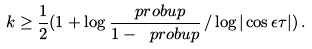Convert formula to latex. <formula><loc_0><loc_0><loc_500><loc_500>k \geq \frac { 1 } { 2 } ( 1 + \log \frac { \ p r o b u p } { 1 - \ p r o b u p } \, / \log | \cos \epsilon \tau | ) \, .</formula> 